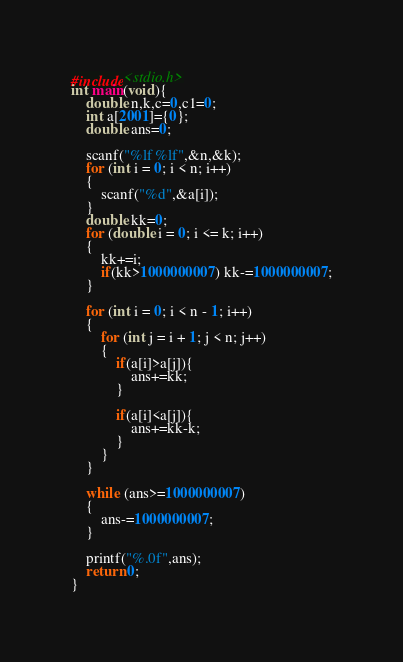Convert code to text. <code><loc_0><loc_0><loc_500><loc_500><_C_>#include<stdio.h>
int main(void){
    double n,k,c=0,c1=0;
    int a[2001]={0};
    double ans=0;

    scanf("%lf %lf",&n,&k);
    for (int i = 0; i < n; i++)
    {
        scanf("%d",&a[i]);
    }
    double kk=0;
    for (double i = 0; i <= k; i++)
    {
        kk+=i;
        if(kk>1000000007) kk-=1000000007;
    }
    
    for (int i = 0; i < n - 1; i++)
    {
        for (int j = i + 1; j < n; j++)
        {
            if(a[i]>a[j]){
                ans+=kk;
            }

            if(a[i]<a[j]){
                ans+=kk-k;
            }
        }       
    }
    
    while (ans>=1000000007)
    {
        ans-=1000000007;
    }

    printf("%.0f",ans);
    return 0;
}</code> 